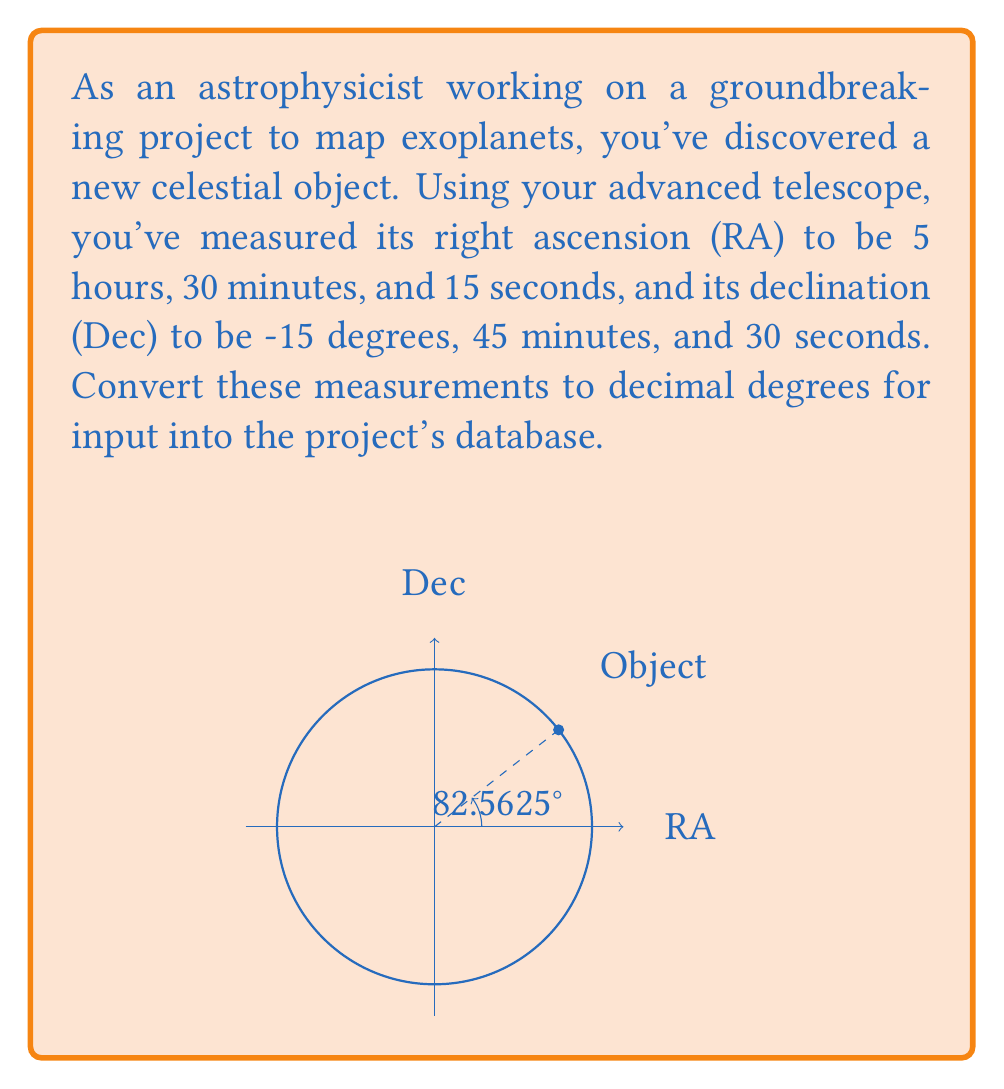Show me your answer to this math problem. To convert the given coordinates to decimal degrees, we need to follow these steps:

1. Convert Right Ascension (RA) to degrees:
   RA is given in hours, minutes, and seconds. We need to convert this to degrees.
   
   $$ RA = 5h \, 30m \, 15s $$
   
   First, convert to decimal hours:
   $$ 5 + \frac{30}{60} + \frac{15}{3600} = 5.50416667 \text{ hours} $$
   
   Now, convert hours to degrees (1 hour = 15 degrees):
   $$ 5.50416667 \times 15 = 82.5625° $$

2. Convert Declination (Dec) to decimal degrees:
   Dec is already in degrees, minutes, and seconds, but we need to convert it to decimal degrees.
   
   $$ Dec = -15° \, 45' \, 30" $$
   
   Convert to decimal degrees:
   $$ -15 - \frac{45}{60} - \frac{30}{3600} = -15.7583333° $$

3. The negative sign in declination indicates that the object is in the southern celestial hemisphere.

Therefore, the coordinates in decimal degrees are:
RA = 82.5625°
Dec = -15.7583333°
Answer: (82.5625°, -15.7583333°) 